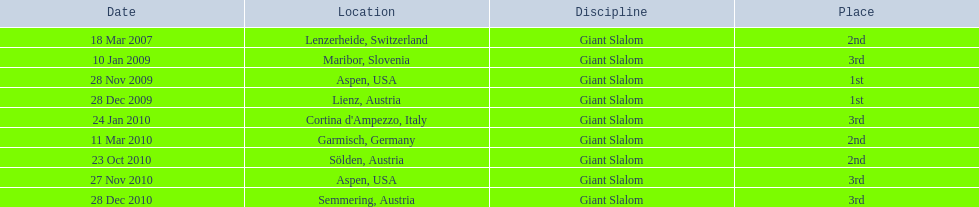What was the final ranking of the last race that took place in december 2010? 3rd. 